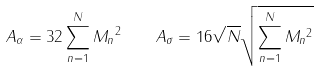<formula> <loc_0><loc_0><loc_500><loc_500>A _ { \alpha } = 3 2 \sum _ { n = 1 } ^ { N } \| M _ { n } \| ^ { 2 } \quad A _ { \sigma } = 1 6 \sqrt { N } \sqrt { \sum _ { n = 1 } ^ { N } \| M _ { n } \| ^ { 2 } }</formula> 